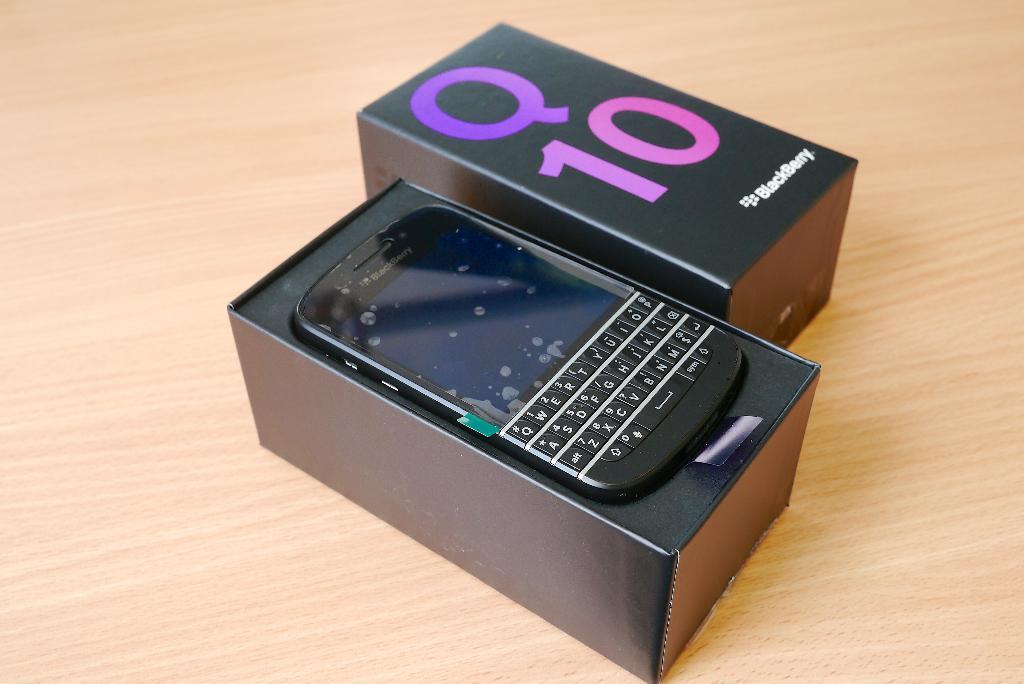What brand is this?
Provide a succinct answer. Blackberry. What model of blackberry phone is this?
Offer a terse response. Q10. 